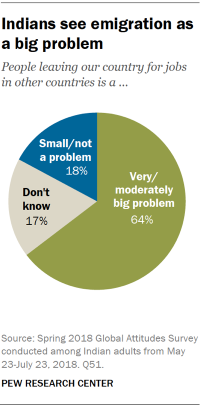List a handful of essential elements in this visual. The sum of 'Don't know' and 'Small /not a probelm' is not more than 'Very /moderately big problem'. The blue color in the pie graph indicates that the problem is small and not significant. 